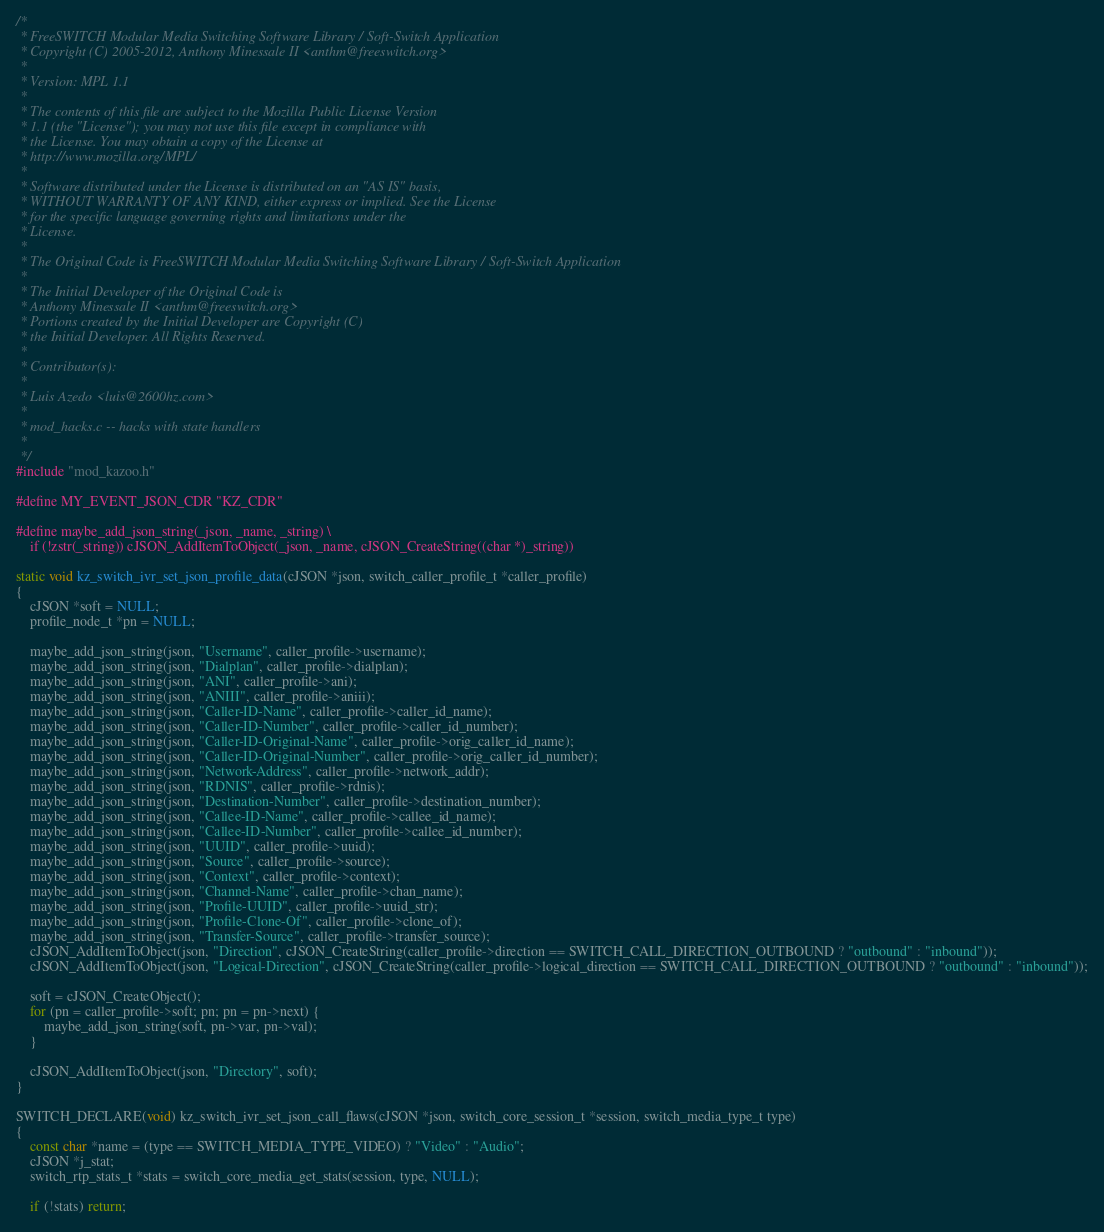Convert code to text. <code><loc_0><loc_0><loc_500><loc_500><_C_>/*
 * FreeSWITCH Modular Media Switching Software Library / Soft-Switch Application
 * Copyright (C) 2005-2012, Anthony Minessale II <anthm@freeswitch.org>
 *
 * Version: MPL 1.1
 *
 * The contents of this file are subject to the Mozilla Public License Version
 * 1.1 (the "License"); you may not use this file except in compliance with
 * the License. You may obtain a copy of the License at
 * http://www.mozilla.org/MPL/
 *
 * Software distributed under the License is distributed on an "AS IS" basis,
 * WITHOUT WARRANTY OF ANY KIND, either express or implied. See the License
 * for the specific language governing rights and limitations under the
 * License.
 *
 * The Original Code is FreeSWITCH Modular Media Switching Software Library / Soft-Switch Application
 *
 * The Initial Developer of the Original Code is
 * Anthony Minessale II <anthm@freeswitch.org>
 * Portions created by the Initial Developer are Copyright (C)
 * the Initial Developer. All Rights Reserved.
 *
 * Contributor(s):
 *
 * Luis Azedo <luis@2600hz.com>
 *
 * mod_hacks.c -- hacks with state handlers
 *
 */
#include "mod_kazoo.h"

#define MY_EVENT_JSON_CDR "KZ_CDR"

#define maybe_add_json_string(_json, _name, _string) \
	if (!zstr(_string)) cJSON_AddItemToObject(_json, _name, cJSON_CreateString((char *)_string))

static void kz_switch_ivr_set_json_profile_data(cJSON *json, switch_caller_profile_t *caller_profile)
{
	cJSON *soft = NULL;
	profile_node_t *pn = NULL;

	maybe_add_json_string(json, "Username", caller_profile->username);
	maybe_add_json_string(json, "Dialplan", caller_profile->dialplan);
	maybe_add_json_string(json, "ANI", caller_profile->ani);
	maybe_add_json_string(json, "ANIII", caller_profile->aniii);
	maybe_add_json_string(json, "Caller-ID-Name", caller_profile->caller_id_name);
	maybe_add_json_string(json, "Caller-ID-Number", caller_profile->caller_id_number);
	maybe_add_json_string(json, "Caller-ID-Original-Name", caller_profile->orig_caller_id_name);
	maybe_add_json_string(json, "Caller-ID-Original-Number", caller_profile->orig_caller_id_number);
	maybe_add_json_string(json, "Network-Address", caller_profile->network_addr);
	maybe_add_json_string(json, "RDNIS", caller_profile->rdnis);
	maybe_add_json_string(json, "Destination-Number", caller_profile->destination_number);
	maybe_add_json_string(json, "Callee-ID-Name", caller_profile->callee_id_name);
	maybe_add_json_string(json, "Callee-ID-Number", caller_profile->callee_id_number);
	maybe_add_json_string(json, "UUID", caller_profile->uuid);
	maybe_add_json_string(json, "Source", caller_profile->source);
	maybe_add_json_string(json, "Context", caller_profile->context);
	maybe_add_json_string(json, "Channel-Name", caller_profile->chan_name);
	maybe_add_json_string(json, "Profile-UUID", caller_profile->uuid_str);
	maybe_add_json_string(json, "Profile-Clone-Of", caller_profile->clone_of);
	maybe_add_json_string(json, "Transfer-Source", caller_profile->transfer_source);
	cJSON_AddItemToObject(json, "Direction", cJSON_CreateString(caller_profile->direction == SWITCH_CALL_DIRECTION_OUTBOUND ? "outbound" : "inbound"));
	cJSON_AddItemToObject(json, "Logical-Direction", cJSON_CreateString(caller_profile->logical_direction == SWITCH_CALL_DIRECTION_OUTBOUND ? "outbound" : "inbound"));

	soft = cJSON_CreateObject();
	for (pn = caller_profile->soft; pn; pn = pn->next) {
		maybe_add_json_string(soft, pn->var, pn->val);
	}

	cJSON_AddItemToObject(json, "Directory", soft);
}

SWITCH_DECLARE(void) kz_switch_ivr_set_json_call_flaws(cJSON *json, switch_core_session_t *session, switch_media_type_t type)
{
	const char *name = (type == SWITCH_MEDIA_TYPE_VIDEO) ? "Video" : "Audio";
	cJSON *j_stat;
	switch_rtp_stats_t *stats = switch_core_media_get_stats(session, type, NULL);

	if (!stats) return;
</code> 